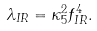Convert formula to latex. <formula><loc_0><loc_0><loc_500><loc_500>\lambda _ { I R } = \kappa _ { 5 } ^ { 2 } f _ { I R } ^ { 4 } .</formula> 